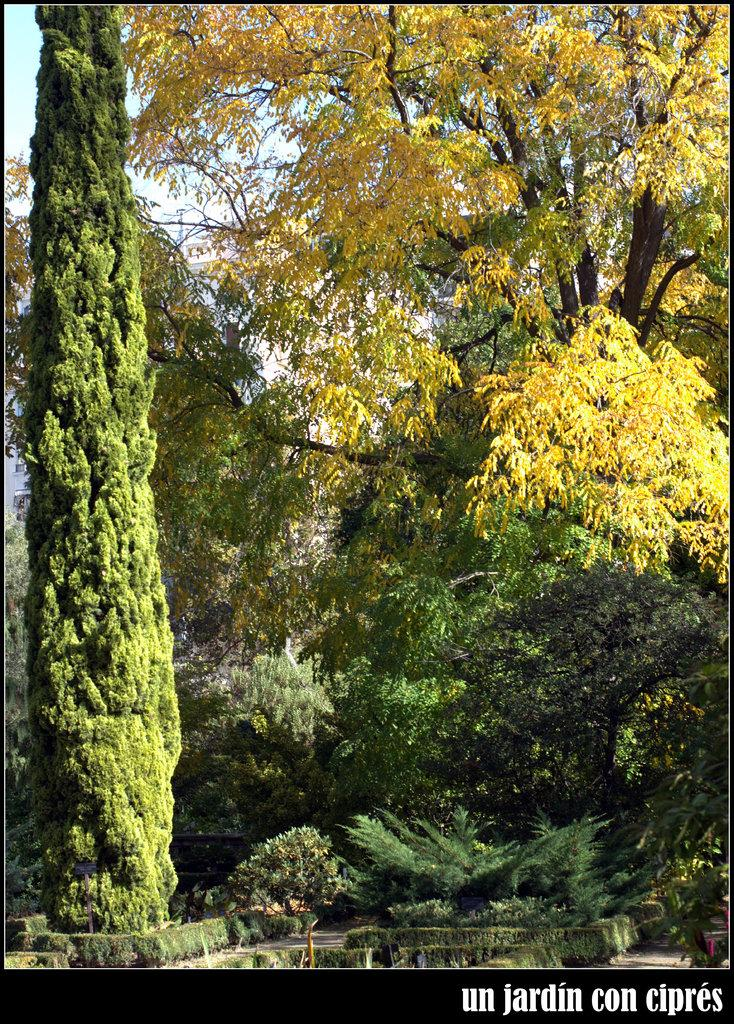What type of outdoor space is depicted in the image? There is a garden in the image. What can be found within the garden? The garden contains plants and trees. What is the ground cover in the garden? There is grass in the garden. What is located in front of the garden? There is a watermark in front of the garden. What can be seen in the sky in the background of the image? The sky is blue in the background, and there are clouds visible. What type of celery is being used in the operation depicted in the image? There is no operation or celery present in the image; it features a garden with plants, trees, grass, a watermark, and a blue sky with clouds. 